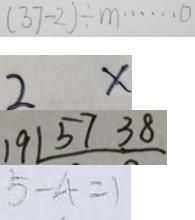<formula> <loc_0><loc_0><loc_500><loc_500>( 3 7 - 2 ) \div m \cdots 0 
 2 x 
 1 9 1 5 7 3 8 
 5 - 4 = 1</formula> 